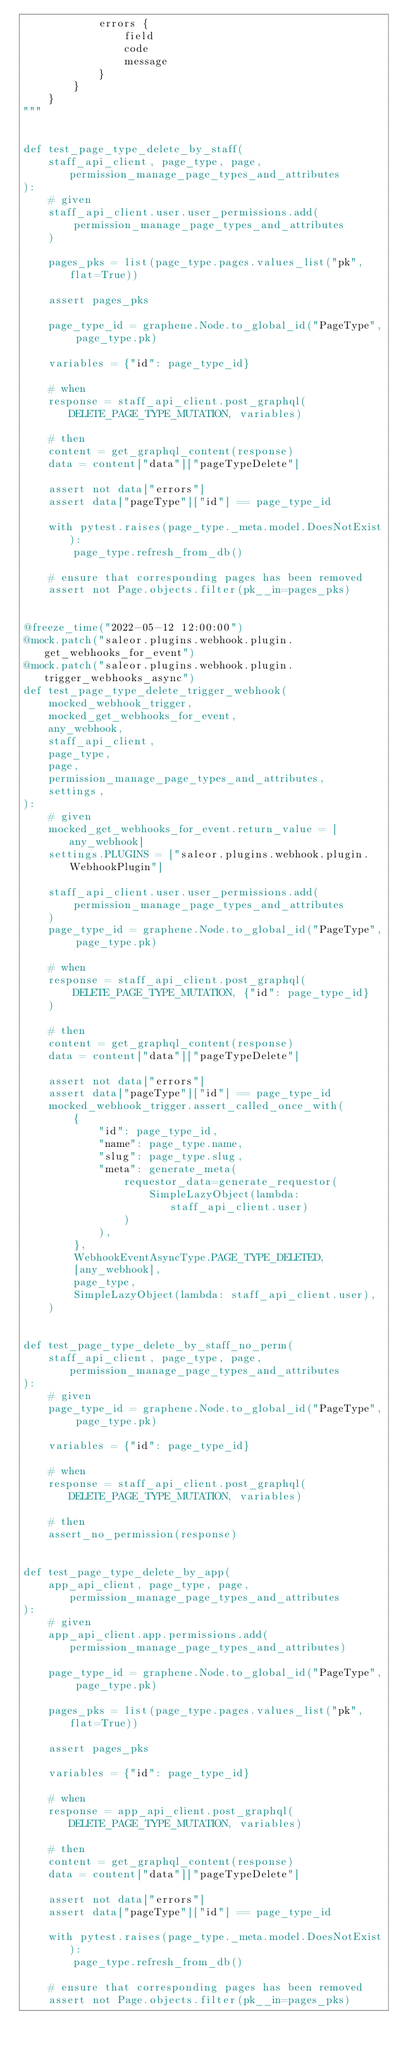Convert code to text. <code><loc_0><loc_0><loc_500><loc_500><_Python_>            errors {
                field
                code
                message
            }
        }
    }
"""


def test_page_type_delete_by_staff(
    staff_api_client, page_type, page, permission_manage_page_types_and_attributes
):
    # given
    staff_api_client.user.user_permissions.add(
        permission_manage_page_types_and_attributes
    )

    pages_pks = list(page_type.pages.values_list("pk", flat=True))

    assert pages_pks

    page_type_id = graphene.Node.to_global_id("PageType", page_type.pk)

    variables = {"id": page_type_id}

    # when
    response = staff_api_client.post_graphql(DELETE_PAGE_TYPE_MUTATION, variables)

    # then
    content = get_graphql_content(response)
    data = content["data"]["pageTypeDelete"]

    assert not data["errors"]
    assert data["pageType"]["id"] == page_type_id

    with pytest.raises(page_type._meta.model.DoesNotExist):
        page_type.refresh_from_db()

    # ensure that corresponding pages has been removed
    assert not Page.objects.filter(pk__in=pages_pks)


@freeze_time("2022-05-12 12:00:00")
@mock.patch("saleor.plugins.webhook.plugin.get_webhooks_for_event")
@mock.patch("saleor.plugins.webhook.plugin.trigger_webhooks_async")
def test_page_type_delete_trigger_webhook(
    mocked_webhook_trigger,
    mocked_get_webhooks_for_event,
    any_webhook,
    staff_api_client,
    page_type,
    page,
    permission_manage_page_types_and_attributes,
    settings,
):
    # given
    mocked_get_webhooks_for_event.return_value = [any_webhook]
    settings.PLUGINS = ["saleor.plugins.webhook.plugin.WebhookPlugin"]

    staff_api_client.user.user_permissions.add(
        permission_manage_page_types_and_attributes
    )
    page_type_id = graphene.Node.to_global_id("PageType", page_type.pk)

    # when
    response = staff_api_client.post_graphql(
        DELETE_PAGE_TYPE_MUTATION, {"id": page_type_id}
    )

    # then
    content = get_graphql_content(response)
    data = content["data"]["pageTypeDelete"]

    assert not data["errors"]
    assert data["pageType"]["id"] == page_type_id
    mocked_webhook_trigger.assert_called_once_with(
        {
            "id": page_type_id,
            "name": page_type.name,
            "slug": page_type.slug,
            "meta": generate_meta(
                requestor_data=generate_requestor(
                    SimpleLazyObject(lambda: staff_api_client.user)
                )
            ),
        },
        WebhookEventAsyncType.PAGE_TYPE_DELETED,
        [any_webhook],
        page_type,
        SimpleLazyObject(lambda: staff_api_client.user),
    )


def test_page_type_delete_by_staff_no_perm(
    staff_api_client, page_type, page, permission_manage_page_types_and_attributes
):
    # given
    page_type_id = graphene.Node.to_global_id("PageType", page_type.pk)

    variables = {"id": page_type_id}

    # when
    response = staff_api_client.post_graphql(DELETE_PAGE_TYPE_MUTATION, variables)

    # then
    assert_no_permission(response)


def test_page_type_delete_by_app(
    app_api_client, page_type, page, permission_manage_page_types_and_attributes
):
    # given
    app_api_client.app.permissions.add(permission_manage_page_types_and_attributes)

    page_type_id = graphene.Node.to_global_id("PageType", page_type.pk)

    pages_pks = list(page_type.pages.values_list("pk", flat=True))

    assert pages_pks

    variables = {"id": page_type_id}

    # when
    response = app_api_client.post_graphql(DELETE_PAGE_TYPE_MUTATION, variables)

    # then
    content = get_graphql_content(response)
    data = content["data"]["pageTypeDelete"]

    assert not data["errors"]
    assert data["pageType"]["id"] == page_type_id

    with pytest.raises(page_type._meta.model.DoesNotExist):
        page_type.refresh_from_db()

    # ensure that corresponding pages has been removed
    assert not Page.objects.filter(pk__in=pages_pks)

</code> 